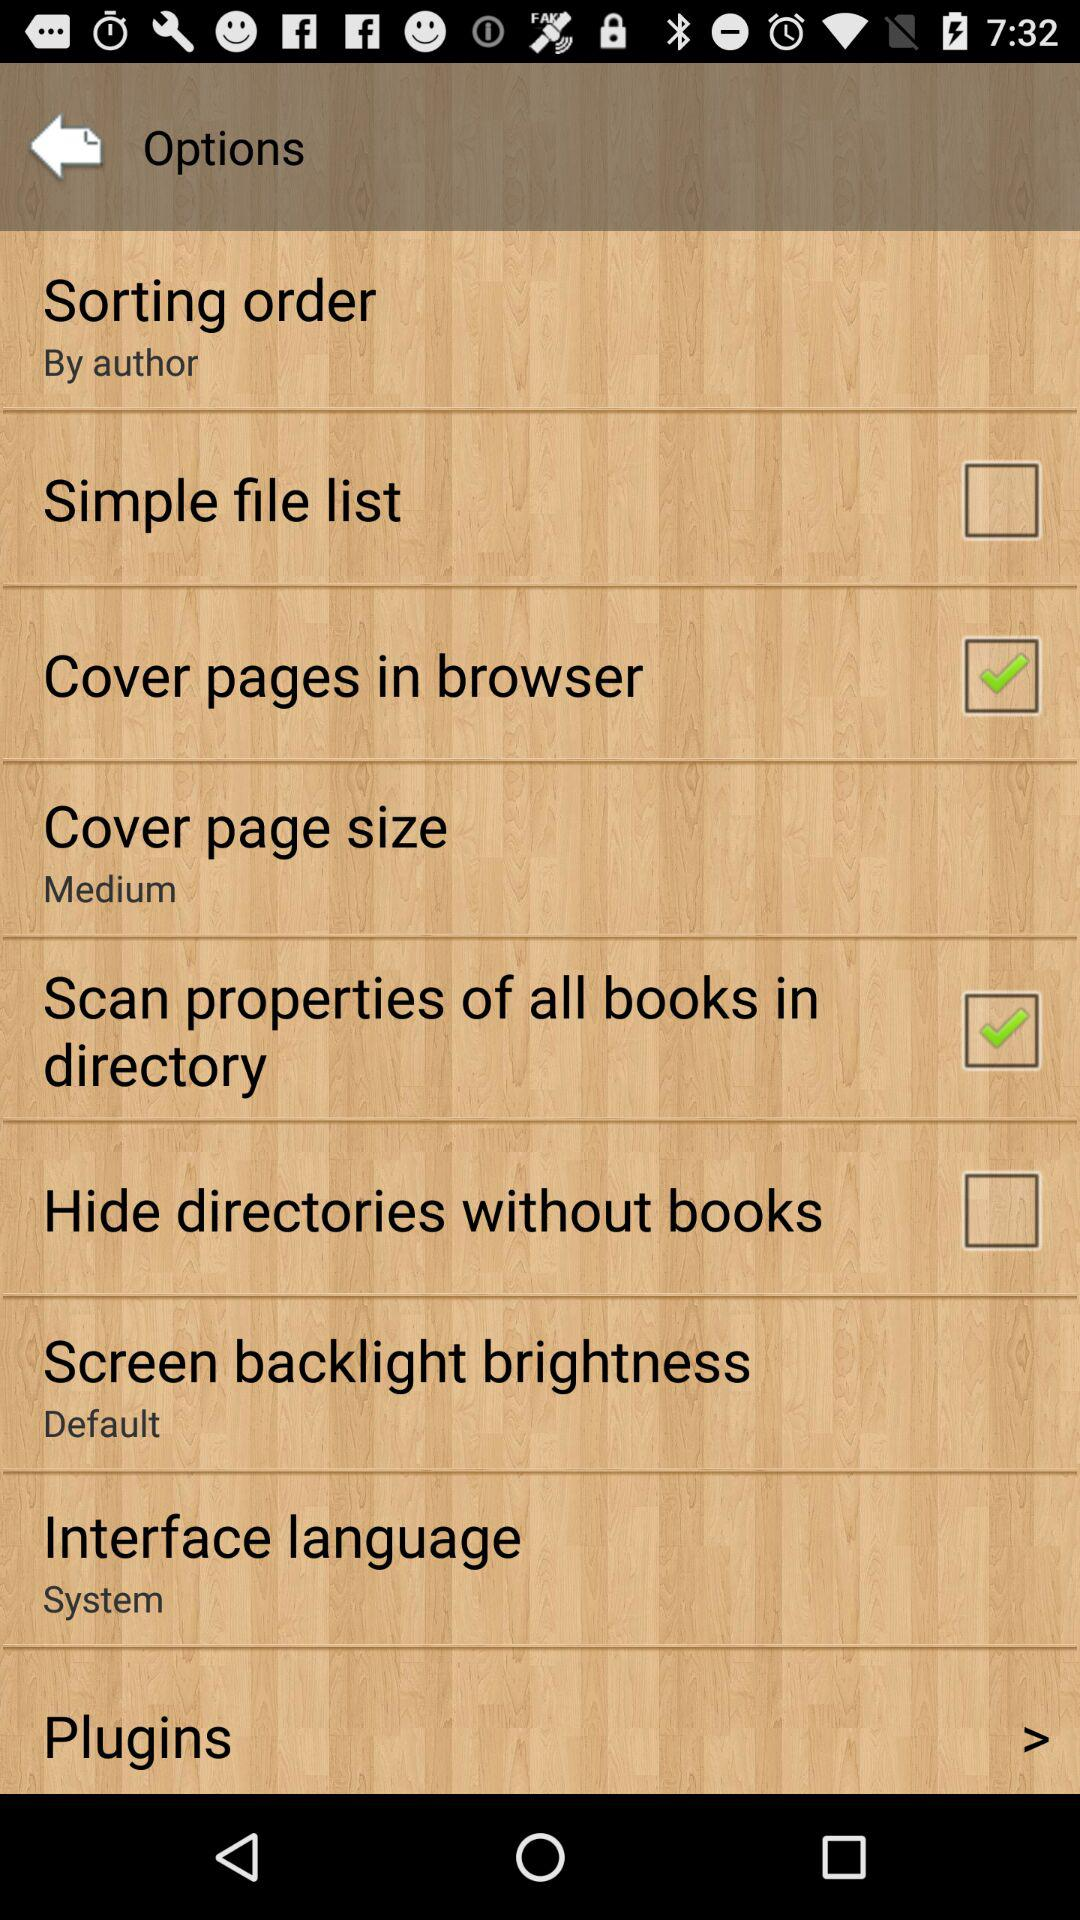What is the status of "Simple file list"? The status is "off". 